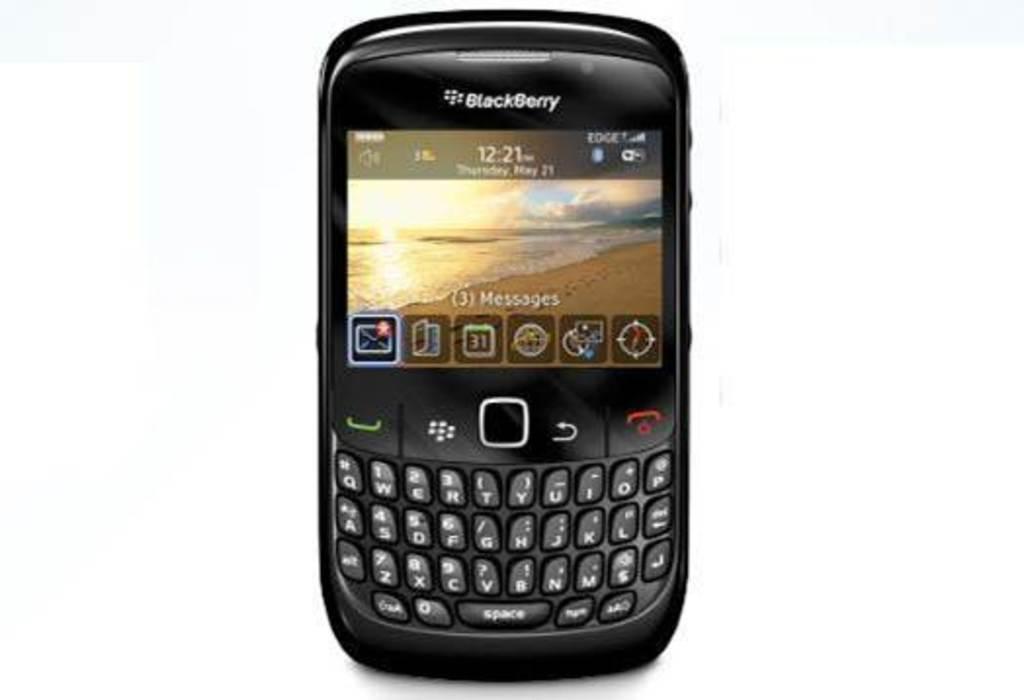What brand of cell phone is this?
Give a very brief answer. Blackberry. What time is shown on the phone?
Keep it short and to the point. 12:21. 